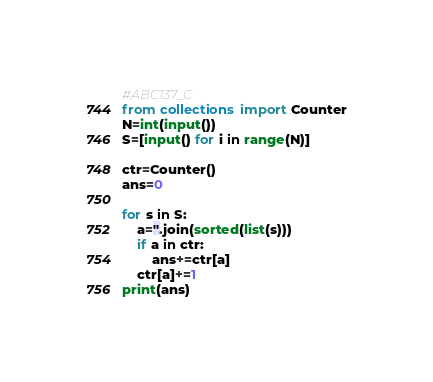<code> <loc_0><loc_0><loc_500><loc_500><_Python_>#ABC137_C
from collections import Counter
N=int(input())
S=[input() for i in range(N)]

ctr=Counter()
ans=0

for s in S:
    a=''.join(sorted(list(s)))
    if a in ctr:
        ans+=ctr[a]
    ctr[a]+=1
print(ans)</code> 